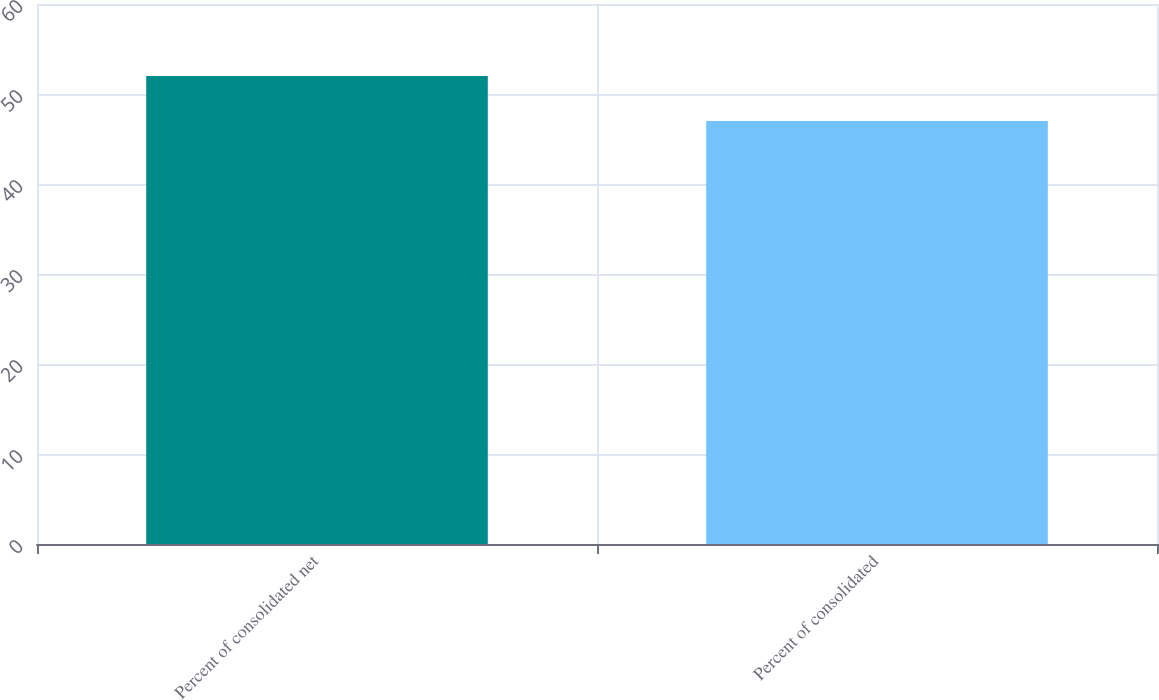<chart> <loc_0><loc_0><loc_500><loc_500><bar_chart><fcel>Percent of consolidated net<fcel>Percent of consolidated<nl><fcel>52<fcel>47<nl></chart> 